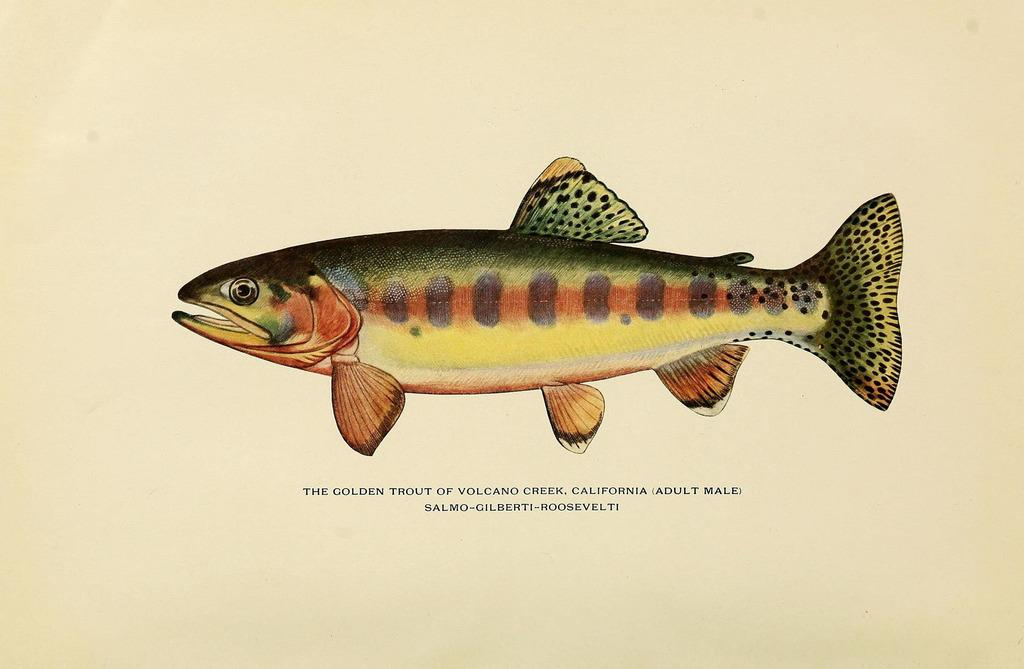What is featured on the poster in the image? There is a poster in the image, and it contains a fist. Is there any text on the poster? Yes, there is text at the bottom of the poster. What type of detail can be seen on the volcano in the image? There is no volcano present in the image; it features a poster with a fist and text. What is the root of the tree in the image? There is no tree present in the image; it features a poster with a fist and text. 